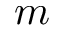<formula> <loc_0><loc_0><loc_500><loc_500>m</formula> 